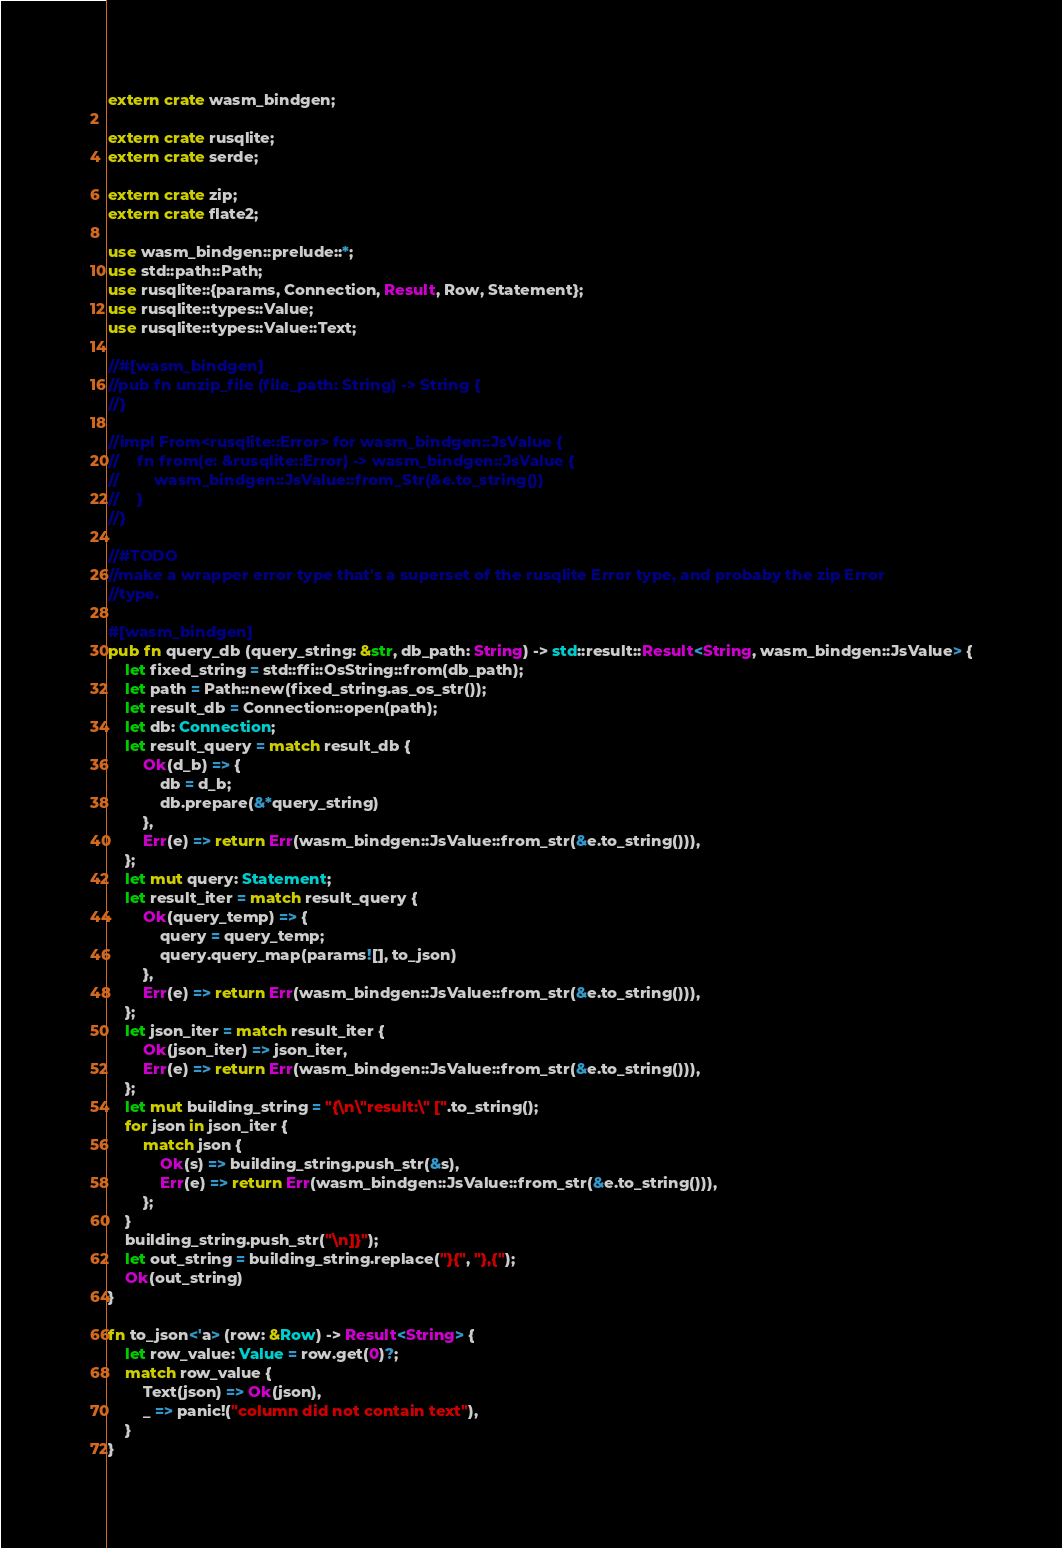<code> <loc_0><loc_0><loc_500><loc_500><_Rust_>extern crate wasm_bindgen;

extern crate rusqlite;
extern crate serde;

extern crate zip;
extern crate flate2;

use wasm_bindgen::prelude::*;
use std::path::Path;
use rusqlite::{params, Connection, Result, Row, Statement};
use rusqlite::types::Value;
use rusqlite::types::Value::Text;

//#[wasm_bindgen]
//pub fn unzip_file (file_path: String) -> String {
//}

//impl From<rusqlite::Error> for wasm_bindgen::JsValue {
//    fn from(e: &rusqlite::Error) -> wasm_bindgen::JsValue {
//        wasm_bindgen::JsValue::from_Str(&e.to_string())
//    }
//}

//#TODO
//make a wrapper error type that's a superset of the rusqlite Error type, and probaby the zip Error
//type.

#[wasm_bindgen]
pub fn query_db (query_string: &str, db_path: String) -> std::result::Result<String, wasm_bindgen::JsValue> {
    let fixed_string = std::ffi::OsString::from(db_path);
    let path = Path::new(fixed_string.as_os_str());
    let result_db = Connection::open(path);
    let db: Connection;
    let result_query = match result_db {
        Ok(d_b) => {
            db = d_b;
            db.prepare(&*query_string)
        },
        Err(e) => return Err(wasm_bindgen::JsValue::from_str(&e.to_string())),
    };
    let mut query: Statement;
    let result_iter = match result_query {
        Ok(query_temp) => {
            query = query_temp;
            query.query_map(params![], to_json)
        },
        Err(e) => return Err(wasm_bindgen::JsValue::from_str(&e.to_string())),
    };
    let json_iter = match result_iter {
        Ok(json_iter) => json_iter,
        Err(e) => return Err(wasm_bindgen::JsValue::from_str(&e.to_string())),
    };
    let mut building_string = "{\n\"result:\" [".to_string();
    for json in json_iter {
        match json {
            Ok(s) => building_string.push_str(&s),
            Err(e) => return Err(wasm_bindgen::JsValue::from_str(&e.to_string())),
        };
    }
    building_string.push_str("\n]}");
    let out_string = building_string.replace("}{", "},{");
    Ok(out_string)
}

fn to_json<'a> (row: &Row) -> Result<String> {
    let row_value: Value = row.get(0)?;
    match row_value {
        Text(json) => Ok(json),
        _ => panic!("column did not contain text"),
    }
}
</code> 